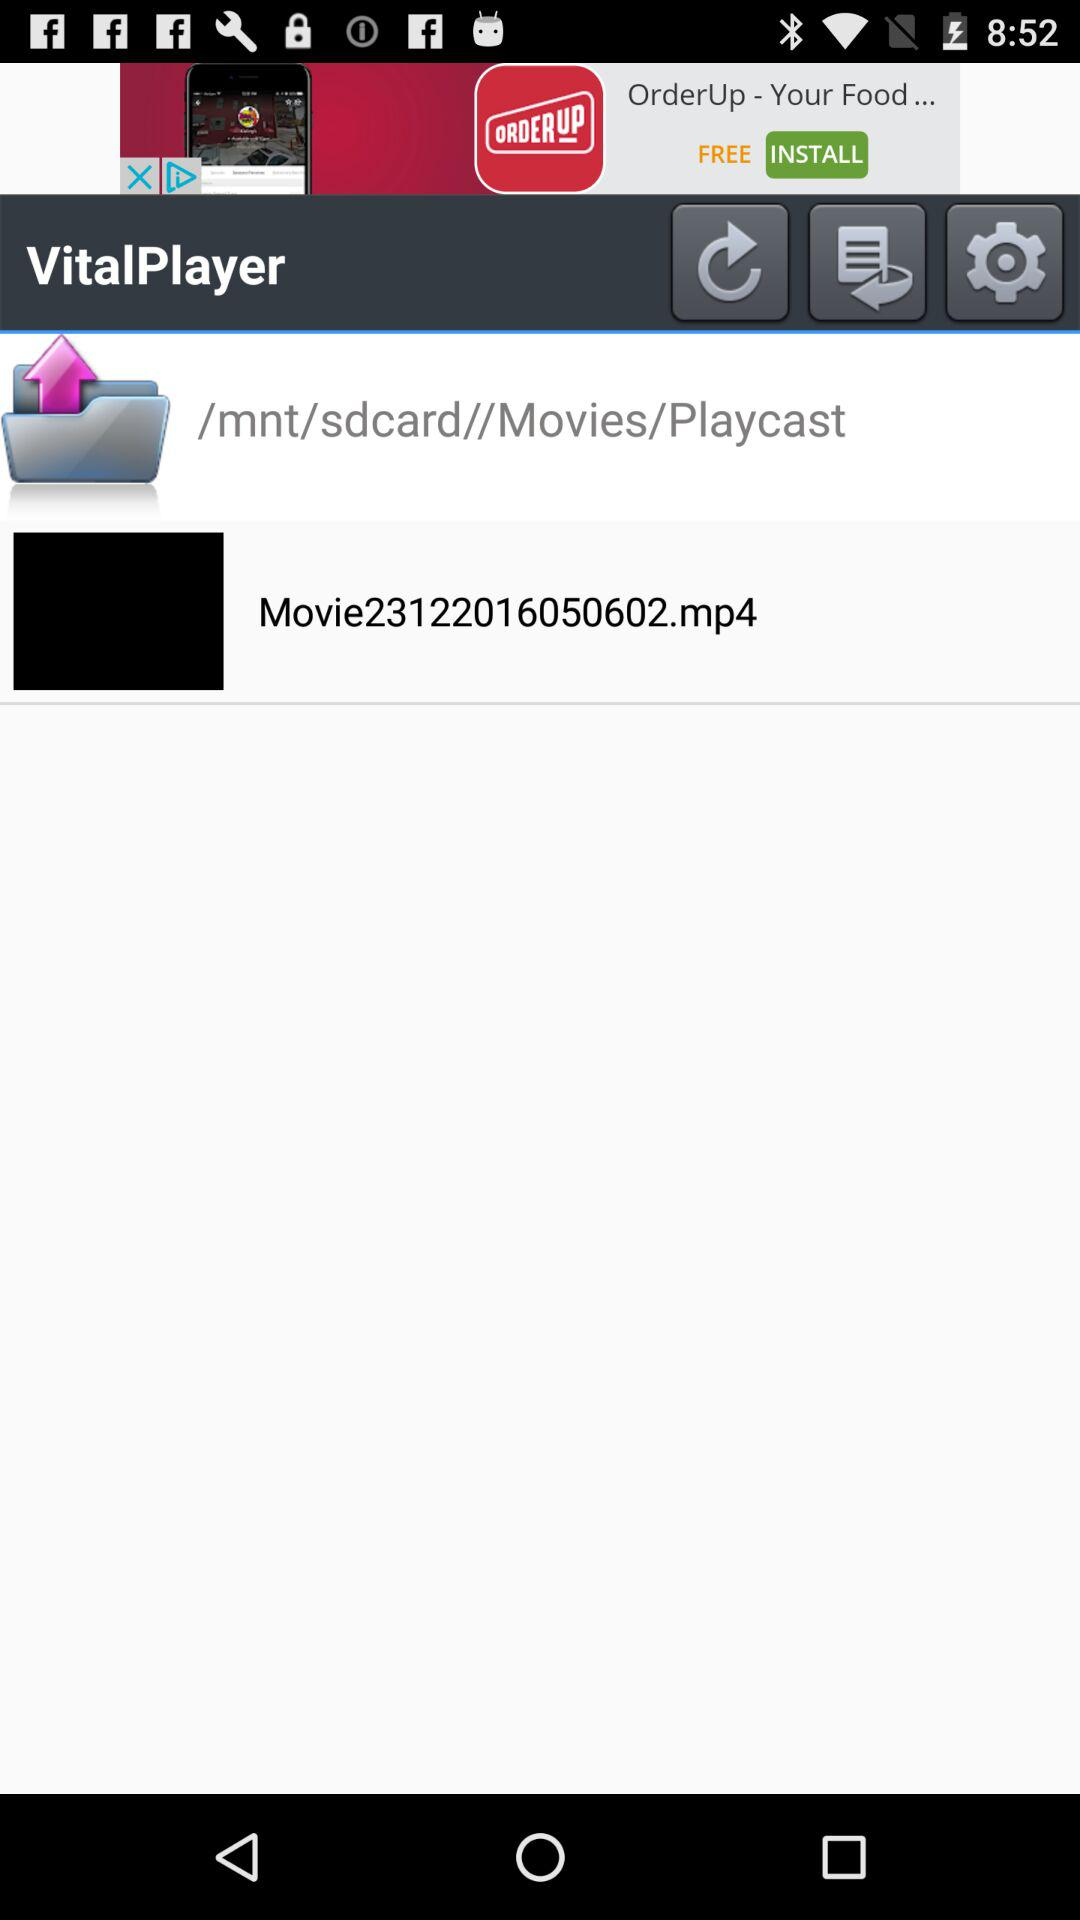How long is the movie?
When the provided information is insufficient, respond with <no answer>. <no answer> 